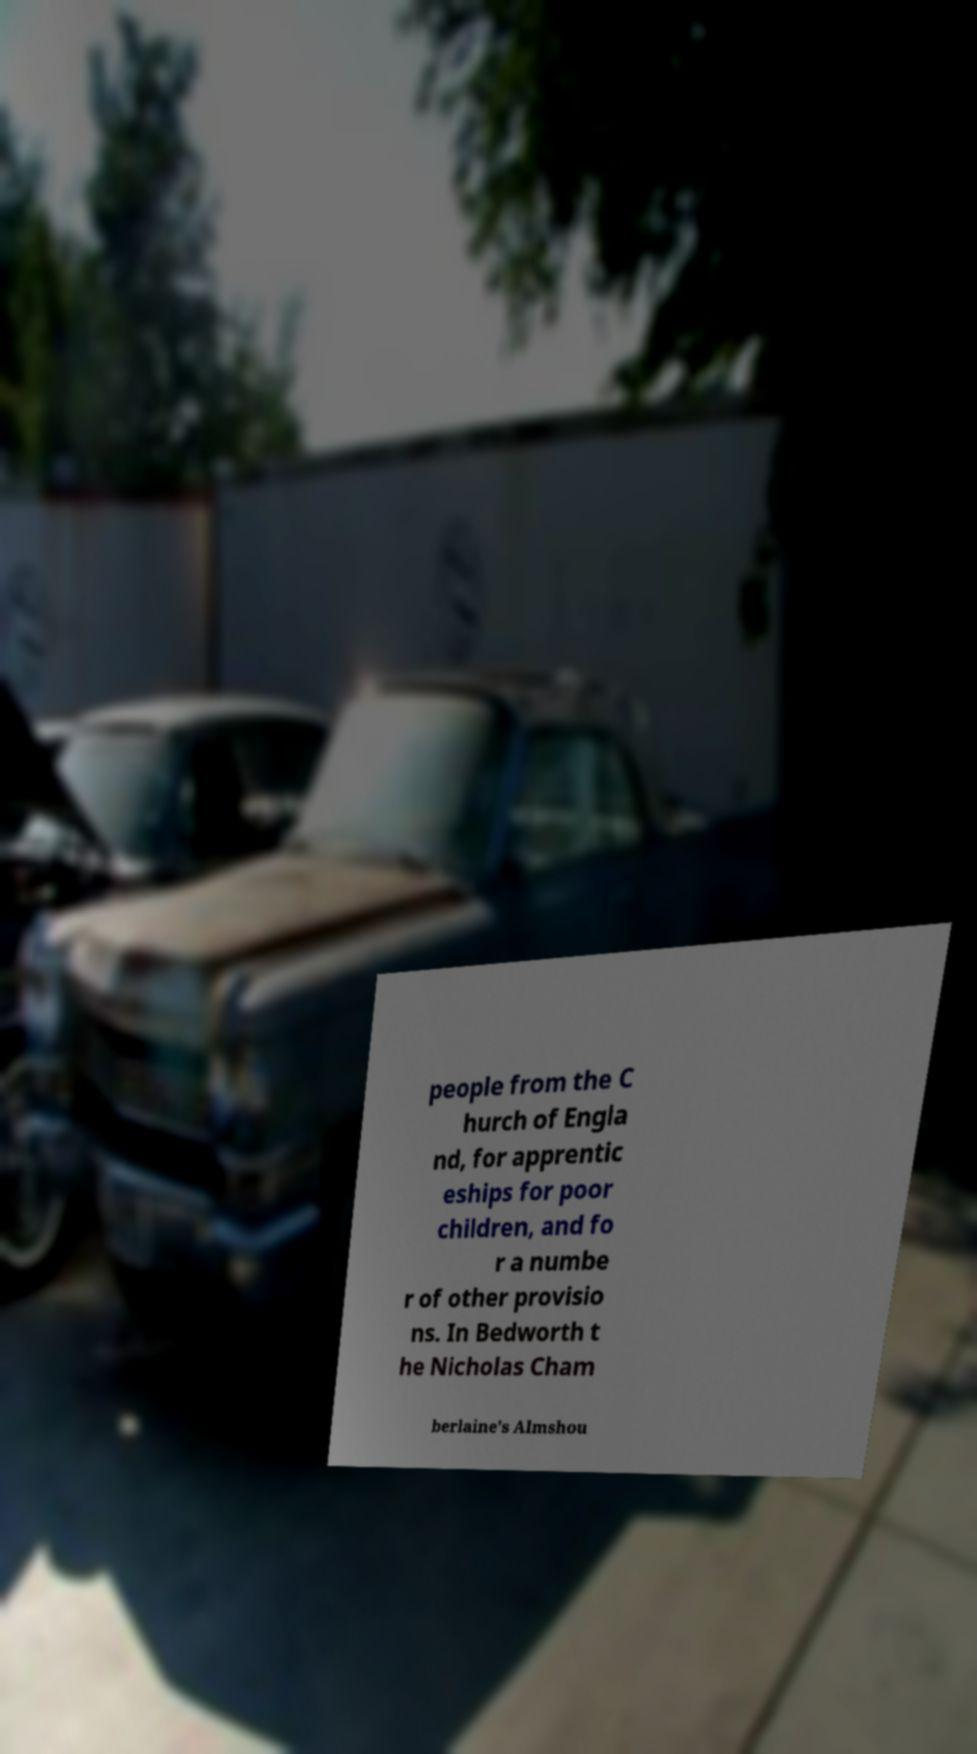Please read and relay the text visible in this image. What does it say? people from the C hurch of Engla nd, for apprentic eships for poor children, and fo r a numbe r of other provisio ns. In Bedworth t he Nicholas Cham berlaine's Almshou 